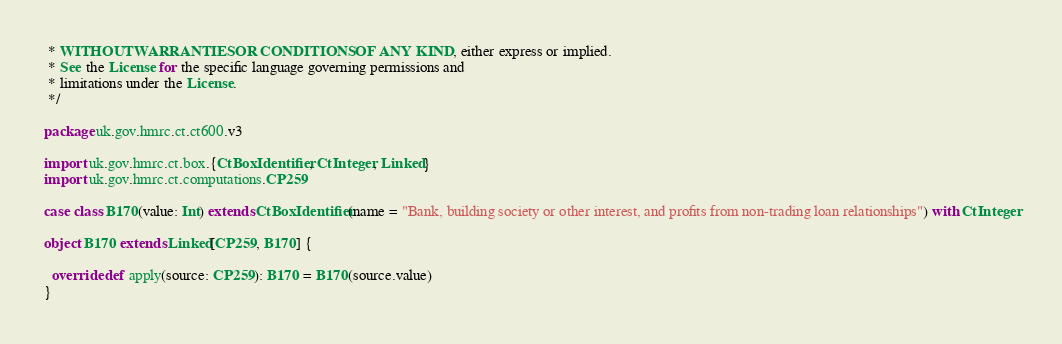Convert code to text. <code><loc_0><loc_0><loc_500><loc_500><_Scala_> * WITHOUT WARRANTIES OR CONDITIONS OF ANY KIND, either express or implied.
 * See the License for the specific language governing permissions and
 * limitations under the License.
 */

package uk.gov.hmrc.ct.ct600.v3

import uk.gov.hmrc.ct.box.{CtBoxIdentifier, CtInteger, Linked}
import uk.gov.hmrc.ct.computations.CP259

case class B170(value: Int) extends CtBoxIdentifier(name = "Bank, building society or other interest, and profits from non-trading loan relationships") with CtInteger

object B170 extends Linked[CP259, B170] {

  override def apply(source: CP259): B170 = B170(source.value)
}
</code> 